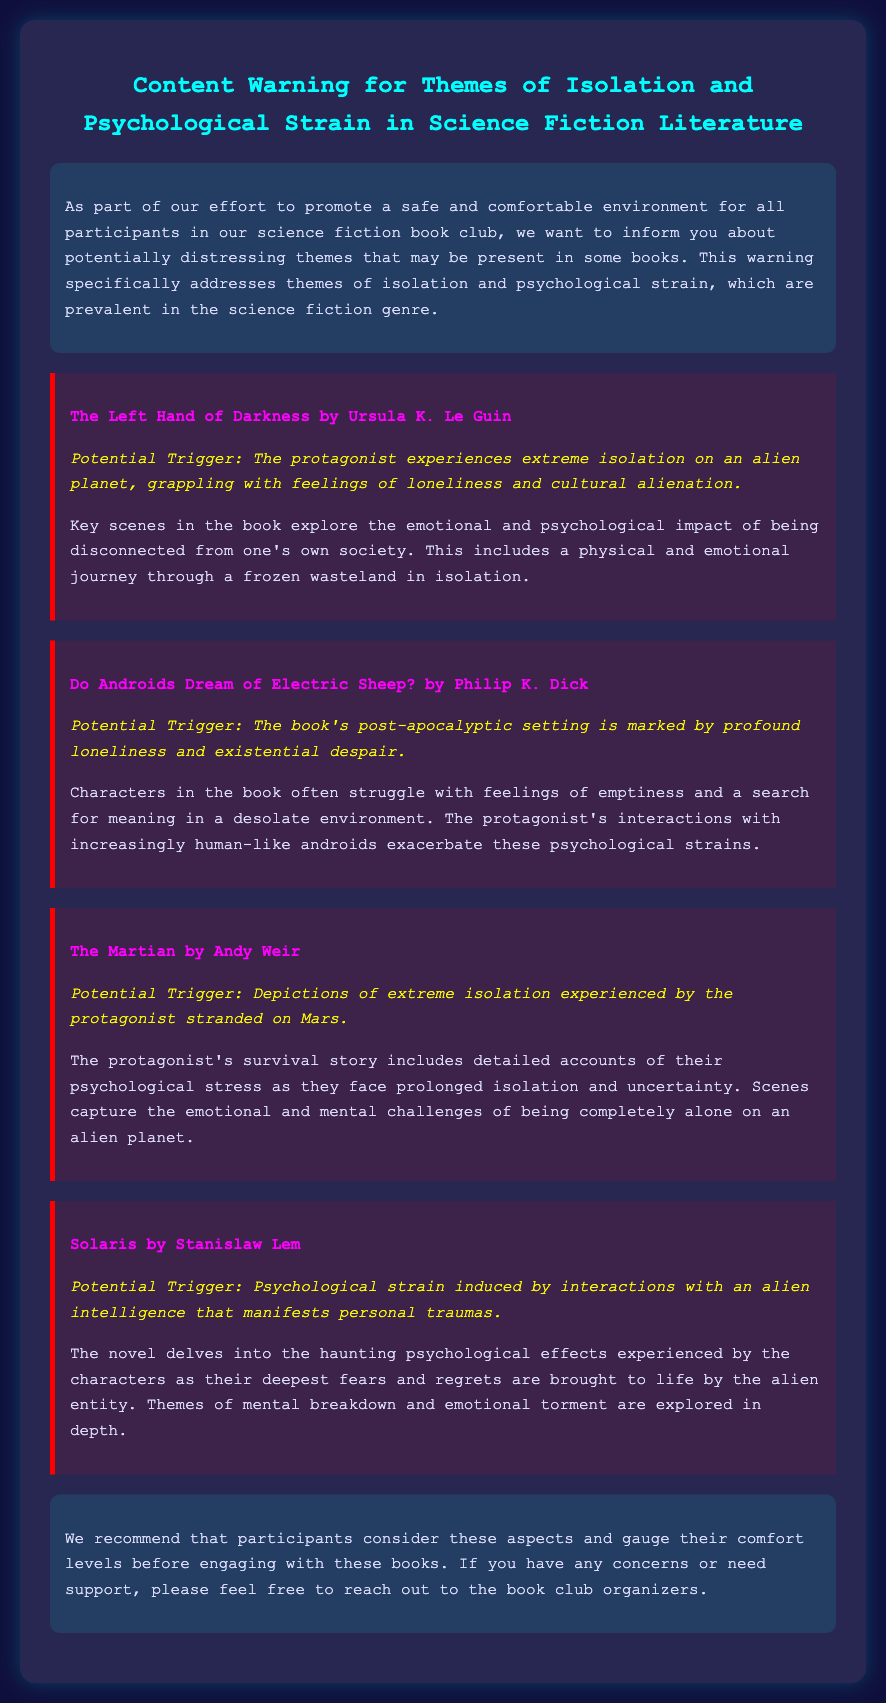What is the title of the first book mentioned? The title of the first book is specified in the document under the first warning section.
Answer: The Left Hand of Darkness by Ursula K. Le Guin What theme is highlighted in this warning label? The document emphasizes certain distressing themes in science fiction literature, addressed in the introduction.
Answer: Isolation and psychological strain How many books are included in the warning label? The total number of books listed can be counted by reviewing the warning sections in the document.
Answer: Four What is the potential trigger for "Do Androids Dream of Electric Sheep?" The potential trigger is described in the warning section for this specific book.
Answer: Profound loneliness and existential despair Which author wrote "Solaris"? The author of this specific book is mentioned under the book title in the warning section.
Answer: Stanislaw Lem What kind of support can participants reach out for? The document offers information about available support after discussing the potentially distressing themes.
Answer: Book club organizers 